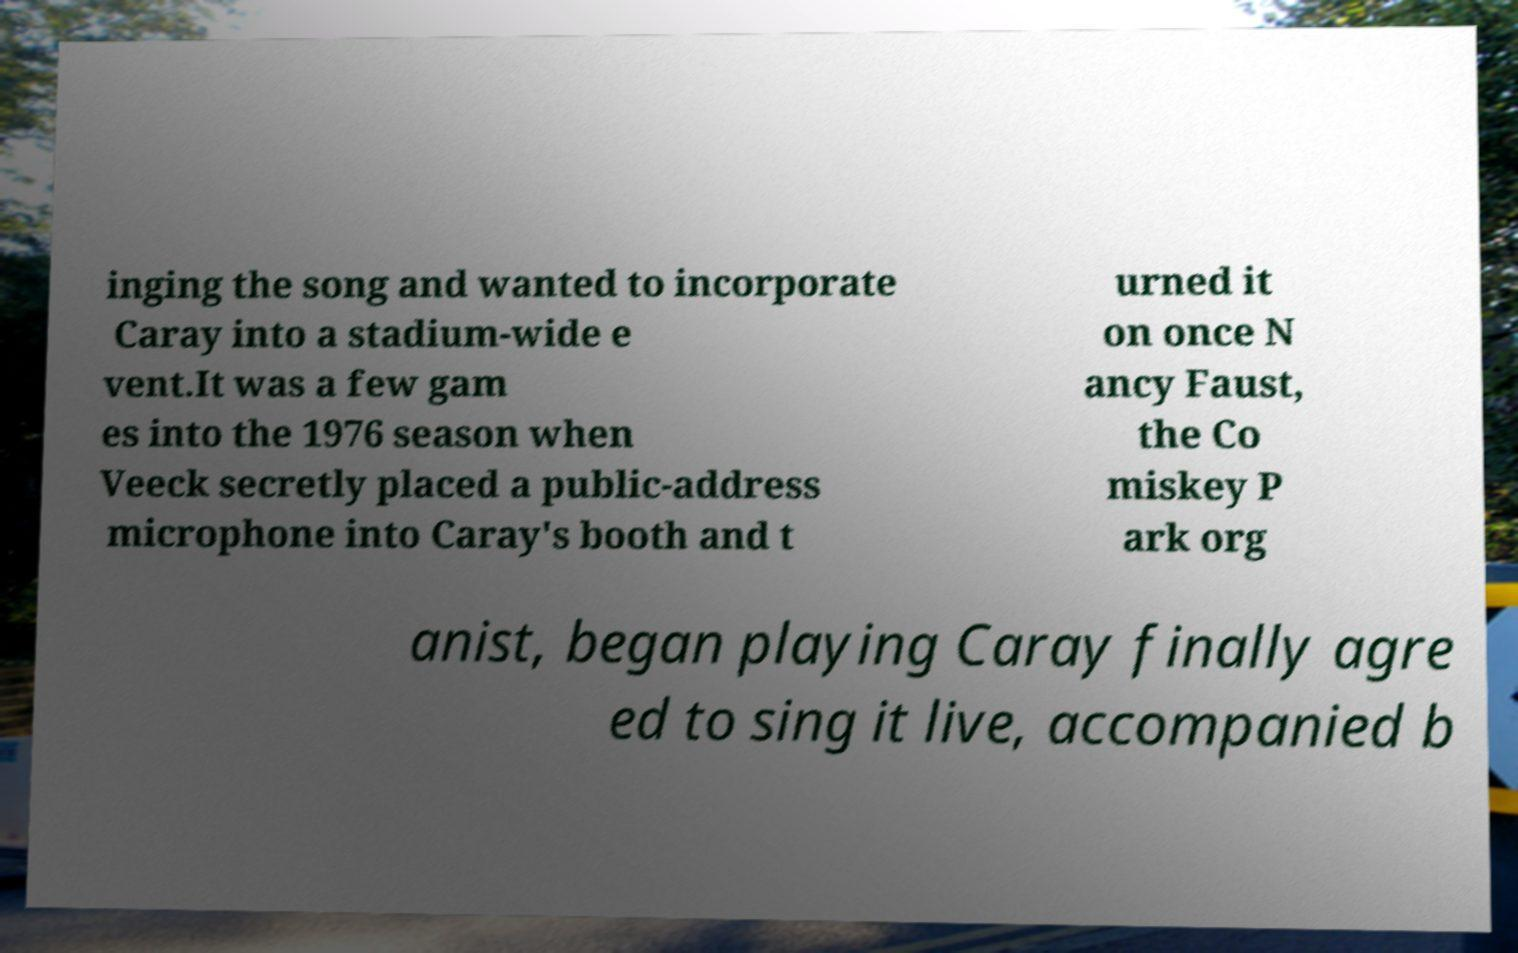Could you extract and type out the text from this image? inging the song and wanted to incorporate Caray into a stadium-wide e vent.It was a few gam es into the 1976 season when Veeck secretly placed a public-address microphone into Caray's booth and t urned it on once N ancy Faust, the Co miskey P ark org anist, began playing Caray finally agre ed to sing it live, accompanied b 